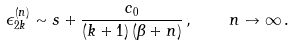<formula> <loc_0><loc_0><loc_500><loc_500>\epsilon ^ { ( n ) } _ { 2 k } \sim s + \frac { c _ { 0 } } { ( k + 1 ) \, ( \beta + n ) } \, , \quad n \to \infty \, .</formula> 